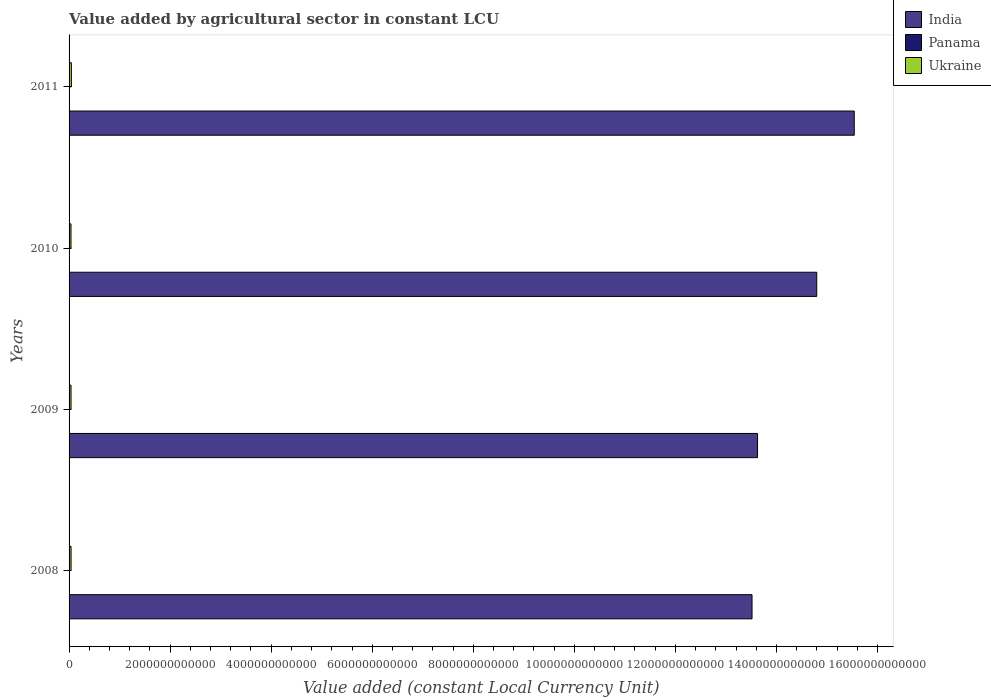How many different coloured bars are there?
Give a very brief answer. 3. How many bars are there on the 4th tick from the top?
Provide a succinct answer. 3. How many bars are there on the 3rd tick from the bottom?
Offer a terse response. 3. What is the value added by agricultural sector in Ukraine in 2009?
Provide a short and direct response. 3.87e+1. Across all years, what is the maximum value added by agricultural sector in Ukraine?
Give a very brief answer. 4.57e+1. Across all years, what is the minimum value added by agricultural sector in Ukraine?
Give a very brief answer. 3.82e+1. What is the total value added by agricultural sector in India in the graph?
Make the answer very short. 5.75e+13. What is the difference between the value added by agricultural sector in India in 2008 and that in 2009?
Offer a very short reply. -1.09e+11. What is the difference between the value added by agricultural sector in Ukraine in 2009 and the value added by agricultural sector in Panama in 2011?
Ensure brevity in your answer.  3.78e+1. What is the average value added by agricultural sector in Ukraine per year?
Make the answer very short. 4.05e+1. In the year 2009, what is the difference between the value added by agricultural sector in Panama and value added by agricultural sector in Ukraine?
Ensure brevity in your answer.  -3.77e+1. What is the ratio of the value added by agricultural sector in Panama in 2008 to that in 2011?
Provide a succinct answer. 1.2. Is the value added by agricultural sector in Panama in 2008 less than that in 2010?
Provide a short and direct response. No. What is the difference between the highest and the second highest value added by agricultural sector in Ukraine?
Make the answer very short. 6.19e+09. What is the difference between the highest and the lowest value added by agricultural sector in India?
Provide a short and direct response. 2.02e+12. Is the sum of the value added by agricultural sector in Ukraine in 2009 and 2011 greater than the maximum value added by agricultural sector in India across all years?
Provide a short and direct response. No. What does the 2nd bar from the top in 2011 represents?
Make the answer very short. Panama. How many bars are there?
Provide a short and direct response. 12. How many years are there in the graph?
Your answer should be very brief. 4. What is the difference between two consecutive major ticks on the X-axis?
Make the answer very short. 2.00e+12. Does the graph contain grids?
Your answer should be compact. No. How many legend labels are there?
Keep it short and to the point. 3. How are the legend labels stacked?
Make the answer very short. Vertical. What is the title of the graph?
Give a very brief answer. Value added by agricultural sector in constant LCU. Does "Serbia" appear as one of the legend labels in the graph?
Your response must be concise. No. What is the label or title of the X-axis?
Offer a terse response. Value added (constant Local Currency Unit). What is the Value added (constant Local Currency Unit) in India in 2008?
Give a very brief answer. 1.35e+13. What is the Value added (constant Local Currency Unit) in Panama in 2008?
Your response must be concise. 1.11e+09. What is the Value added (constant Local Currency Unit) in Ukraine in 2008?
Your answer should be very brief. 3.95e+1. What is the Value added (constant Local Currency Unit) in India in 2009?
Your answer should be very brief. 1.36e+13. What is the Value added (constant Local Currency Unit) in Panama in 2009?
Offer a very short reply. 1.01e+09. What is the Value added (constant Local Currency Unit) in Ukraine in 2009?
Provide a succinct answer. 3.87e+1. What is the Value added (constant Local Currency Unit) in India in 2010?
Offer a terse response. 1.48e+13. What is the Value added (constant Local Currency Unit) of Panama in 2010?
Give a very brief answer. 9.15e+08. What is the Value added (constant Local Currency Unit) of Ukraine in 2010?
Ensure brevity in your answer.  3.82e+1. What is the Value added (constant Local Currency Unit) of India in 2011?
Ensure brevity in your answer.  1.55e+13. What is the Value added (constant Local Currency Unit) of Panama in 2011?
Provide a short and direct response. 9.27e+08. What is the Value added (constant Local Currency Unit) of Ukraine in 2011?
Your answer should be very brief. 4.57e+1. Across all years, what is the maximum Value added (constant Local Currency Unit) of India?
Give a very brief answer. 1.55e+13. Across all years, what is the maximum Value added (constant Local Currency Unit) in Panama?
Offer a very short reply. 1.11e+09. Across all years, what is the maximum Value added (constant Local Currency Unit) in Ukraine?
Offer a very short reply. 4.57e+1. Across all years, what is the minimum Value added (constant Local Currency Unit) in India?
Provide a succinct answer. 1.35e+13. Across all years, what is the minimum Value added (constant Local Currency Unit) of Panama?
Keep it short and to the point. 9.15e+08. Across all years, what is the minimum Value added (constant Local Currency Unit) in Ukraine?
Provide a succinct answer. 3.82e+1. What is the total Value added (constant Local Currency Unit) in India in the graph?
Offer a very short reply. 5.75e+13. What is the total Value added (constant Local Currency Unit) of Panama in the graph?
Your response must be concise. 3.96e+09. What is the total Value added (constant Local Currency Unit) of Ukraine in the graph?
Your answer should be compact. 1.62e+11. What is the difference between the Value added (constant Local Currency Unit) in India in 2008 and that in 2009?
Provide a succinct answer. -1.09e+11. What is the difference between the Value added (constant Local Currency Unit) in Panama in 2008 and that in 2009?
Offer a terse response. 1.08e+08. What is the difference between the Value added (constant Local Currency Unit) in Ukraine in 2008 and that in 2009?
Offer a terse response. 7.90e+08. What is the difference between the Value added (constant Local Currency Unit) of India in 2008 and that in 2010?
Give a very brief answer. -1.28e+12. What is the difference between the Value added (constant Local Currency Unit) of Panama in 2008 and that in 2010?
Make the answer very short. 1.99e+08. What is the difference between the Value added (constant Local Currency Unit) in Ukraine in 2008 and that in 2010?
Provide a succinct answer. 1.29e+09. What is the difference between the Value added (constant Local Currency Unit) in India in 2008 and that in 2011?
Your answer should be compact. -2.02e+12. What is the difference between the Value added (constant Local Currency Unit) of Panama in 2008 and that in 2011?
Provide a short and direct response. 1.87e+08. What is the difference between the Value added (constant Local Currency Unit) in Ukraine in 2008 and that in 2011?
Your response must be concise. -6.19e+09. What is the difference between the Value added (constant Local Currency Unit) of India in 2009 and that in 2010?
Provide a short and direct response. -1.17e+12. What is the difference between the Value added (constant Local Currency Unit) of Panama in 2009 and that in 2010?
Offer a terse response. 9.08e+07. What is the difference between the Value added (constant Local Currency Unit) of Ukraine in 2009 and that in 2010?
Ensure brevity in your answer.  5.03e+08. What is the difference between the Value added (constant Local Currency Unit) in India in 2009 and that in 2011?
Your answer should be compact. -1.91e+12. What is the difference between the Value added (constant Local Currency Unit) of Panama in 2009 and that in 2011?
Offer a very short reply. 7.90e+07. What is the difference between the Value added (constant Local Currency Unit) in Ukraine in 2009 and that in 2011?
Provide a short and direct response. -6.98e+09. What is the difference between the Value added (constant Local Currency Unit) of India in 2010 and that in 2011?
Ensure brevity in your answer.  -7.42e+11. What is the difference between the Value added (constant Local Currency Unit) in Panama in 2010 and that in 2011?
Provide a short and direct response. -1.18e+07. What is the difference between the Value added (constant Local Currency Unit) of Ukraine in 2010 and that in 2011?
Your answer should be compact. -7.49e+09. What is the difference between the Value added (constant Local Currency Unit) of India in 2008 and the Value added (constant Local Currency Unit) of Panama in 2009?
Keep it short and to the point. 1.35e+13. What is the difference between the Value added (constant Local Currency Unit) of India in 2008 and the Value added (constant Local Currency Unit) of Ukraine in 2009?
Your answer should be compact. 1.35e+13. What is the difference between the Value added (constant Local Currency Unit) of Panama in 2008 and the Value added (constant Local Currency Unit) of Ukraine in 2009?
Provide a succinct answer. -3.76e+1. What is the difference between the Value added (constant Local Currency Unit) in India in 2008 and the Value added (constant Local Currency Unit) in Panama in 2010?
Your answer should be very brief. 1.35e+13. What is the difference between the Value added (constant Local Currency Unit) in India in 2008 and the Value added (constant Local Currency Unit) in Ukraine in 2010?
Give a very brief answer. 1.35e+13. What is the difference between the Value added (constant Local Currency Unit) of Panama in 2008 and the Value added (constant Local Currency Unit) of Ukraine in 2010?
Provide a short and direct response. -3.71e+1. What is the difference between the Value added (constant Local Currency Unit) in India in 2008 and the Value added (constant Local Currency Unit) in Panama in 2011?
Offer a very short reply. 1.35e+13. What is the difference between the Value added (constant Local Currency Unit) in India in 2008 and the Value added (constant Local Currency Unit) in Ukraine in 2011?
Offer a very short reply. 1.35e+13. What is the difference between the Value added (constant Local Currency Unit) in Panama in 2008 and the Value added (constant Local Currency Unit) in Ukraine in 2011?
Offer a terse response. -4.46e+1. What is the difference between the Value added (constant Local Currency Unit) of India in 2009 and the Value added (constant Local Currency Unit) of Panama in 2010?
Provide a short and direct response. 1.36e+13. What is the difference between the Value added (constant Local Currency Unit) of India in 2009 and the Value added (constant Local Currency Unit) of Ukraine in 2010?
Offer a very short reply. 1.36e+13. What is the difference between the Value added (constant Local Currency Unit) in Panama in 2009 and the Value added (constant Local Currency Unit) in Ukraine in 2010?
Ensure brevity in your answer.  -3.72e+1. What is the difference between the Value added (constant Local Currency Unit) of India in 2009 and the Value added (constant Local Currency Unit) of Panama in 2011?
Provide a succinct answer. 1.36e+13. What is the difference between the Value added (constant Local Currency Unit) of India in 2009 and the Value added (constant Local Currency Unit) of Ukraine in 2011?
Provide a succinct answer. 1.36e+13. What is the difference between the Value added (constant Local Currency Unit) in Panama in 2009 and the Value added (constant Local Currency Unit) in Ukraine in 2011?
Ensure brevity in your answer.  -4.47e+1. What is the difference between the Value added (constant Local Currency Unit) of India in 2010 and the Value added (constant Local Currency Unit) of Panama in 2011?
Give a very brief answer. 1.48e+13. What is the difference between the Value added (constant Local Currency Unit) in India in 2010 and the Value added (constant Local Currency Unit) in Ukraine in 2011?
Keep it short and to the point. 1.48e+13. What is the difference between the Value added (constant Local Currency Unit) of Panama in 2010 and the Value added (constant Local Currency Unit) of Ukraine in 2011?
Provide a succinct answer. -4.48e+1. What is the average Value added (constant Local Currency Unit) in India per year?
Provide a short and direct response. 1.44e+13. What is the average Value added (constant Local Currency Unit) of Panama per year?
Offer a terse response. 9.90e+08. What is the average Value added (constant Local Currency Unit) of Ukraine per year?
Your answer should be very brief. 4.05e+1. In the year 2008, what is the difference between the Value added (constant Local Currency Unit) of India and Value added (constant Local Currency Unit) of Panama?
Give a very brief answer. 1.35e+13. In the year 2008, what is the difference between the Value added (constant Local Currency Unit) of India and Value added (constant Local Currency Unit) of Ukraine?
Your answer should be compact. 1.35e+13. In the year 2008, what is the difference between the Value added (constant Local Currency Unit) in Panama and Value added (constant Local Currency Unit) in Ukraine?
Keep it short and to the point. -3.84e+1. In the year 2009, what is the difference between the Value added (constant Local Currency Unit) of India and Value added (constant Local Currency Unit) of Panama?
Your answer should be compact. 1.36e+13. In the year 2009, what is the difference between the Value added (constant Local Currency Unit) in India and Value added (constant Local Currency Unit) in Ukraine?
Keep it short and to the point. 1.36e+13. In the year 2009, what is the difference between the Value added (constant Local Currency Unit) in Panama and Value added (constant Local Currency Unit) in Ukraine?
Your answer should be very brief. -3.77e+1. In the year 2010, what is the difference between the Value added (constant Local Currency Unit) of India and Value added (constant Local Currency Unit) of Panama?
Your answer should be very brief. 1.48e+13. In the year 2010, what is the difference between the Value added (constant Local Currency Unit) in India and Value added (constant Local Currency Unit) in Ukraine?
Provide a short and direct response. 1.48e+13. In the year 2010, what is the difference between the Value added (constant Local Currency Unit) in Panama and Value added (constant Local Currency Unit) in Ukraine?
Your answer should be compact. -3.73e+1. In the year 2011, what is the difference between the Value added (constant Local Currency Unit) of India and Value added (constant Local Currency Unit) of Panama?
Your answer should be very brief. 1.55e+13. In the year 2011, what is the difference between the Value added (constant Local Currency Unit) in India and Value added (constant Local Currency Unit) in Ukraine?
Keep it short and to the point. 1.55e+13. In the year 2011, what is the difference between the Value added (constant Local Currency Unit) in Panama and Value added (constant Local Currency Unit) in Ukraine?
Keep it short and to the point. -4.48e+1. What is the ratio of the Value added (constant Local Currency Unit) in India in 2008 to that in 2009?
Your answer should be compact. 0.99. What is the ratio of the Value added (constant Local Currency Unit) in Panama in 2008 to that in 2009?
Ensure brevity in your answer.  1.11. What is the ratio of the Value added (constant Local Currency Unit) of Ukraine in 2008 to that in 2009?
Make the answer very short. 1.02. What is the ratio of the Value added (constant Local Currency Unit) in India in 2008 to that in 2010?
Your answer should be very brief. 0.91. What is the ratio of the Value added (constant Local Currency Unit) of Panama in 2008 to that in 2010?
Your answer should be very brief. 1.22. What is the ratio of the Value added (constant Local Currency Unit) in Ukraine in 2008 to that in 2010?
Ensure brevity in your answer.  1.03. What is the ratio of the Value added (constant Local Currency Unit) in India in 2008 to that in 2011?
Offer a terse response. 0.87. What is the ratio of the Value added (constant Local Currency Unit) in Panama in 2008 to that in 2011?
Offer a terse response. 1.2. What is the ratio of the Value added (constant Local Currency Unit) in Ukraine in 2008 to that in 2011?
Your answer should be compact. 0.86. What is the ratio of the Value added (constant Local Currency Unit) in India in 2009 to that in 2010?
Provide a succinct answer. 0.92. What is the ratio of the Value added (constant Local Currency Unit) in Panama in 2009 to that in 2010?
Make the answer very short. 1.1. What is the ratio of the Value added (constant Local Currency Unit) of Ukraine in 2009 to that in 2010?
Offer a very short reply. 1.01. What is the ratio of the Value added (constant Local Currency Unit) in India in 2009 to that in 2011?
Your answer should be very brief. 0.88. What is the ratio of the Value added (constant Local Currency Unit) in Panama in 2009 to that in 2011?
Your answer should be compact. 1.09. What is the ratio of the Value added (constant Local Currency Unit) in Ukraine in 2009 to that in 2011?
Provide a succinct answer. 0.85. What is the ratio of the Value added (constant Local Currency Unit) of India in 2010 to that in 2011?
Offer a very short reply. 0.95. What is the ratio of the Value added (constant Local Currency Unit) of Panama in 2010 to that in 2011?
Your response must be concise. 0.99. What is the ratio of the Value added (constant Local Currency Unit) in Ukraine in 2010 to that in 2011?
Give a very brief answer. 0.84. What is the difference between the highest and the second highest Value added (constant Local Currency Unit) in India?
Keep it short and to the point. 7.42e+11. What is the difference between the highest and the second highest Value added (constant Local Currency Unit) in Panama?
Provide a succinct answer. 1.08e+08. What is the difference between the highest and the second highest Value added (constant Local Currency Unit) of Ukraine?
Offer a terse response. 6.19e+09. What is the difference between the highest and the lowest Value added (constant Local Currency Unit) of India?
Provide a short and direct response. 2.02e+12. What is the difference between the highest and the lowest Value added (constant Local Currency Unit) in Panama?
Provide a succinct answer. 1.99e+08. What is the difference between the highest and the lowest Value added (constant Local Currency Unit) in Ukraine?
Keep it short and to the point. 7.49e+09. 